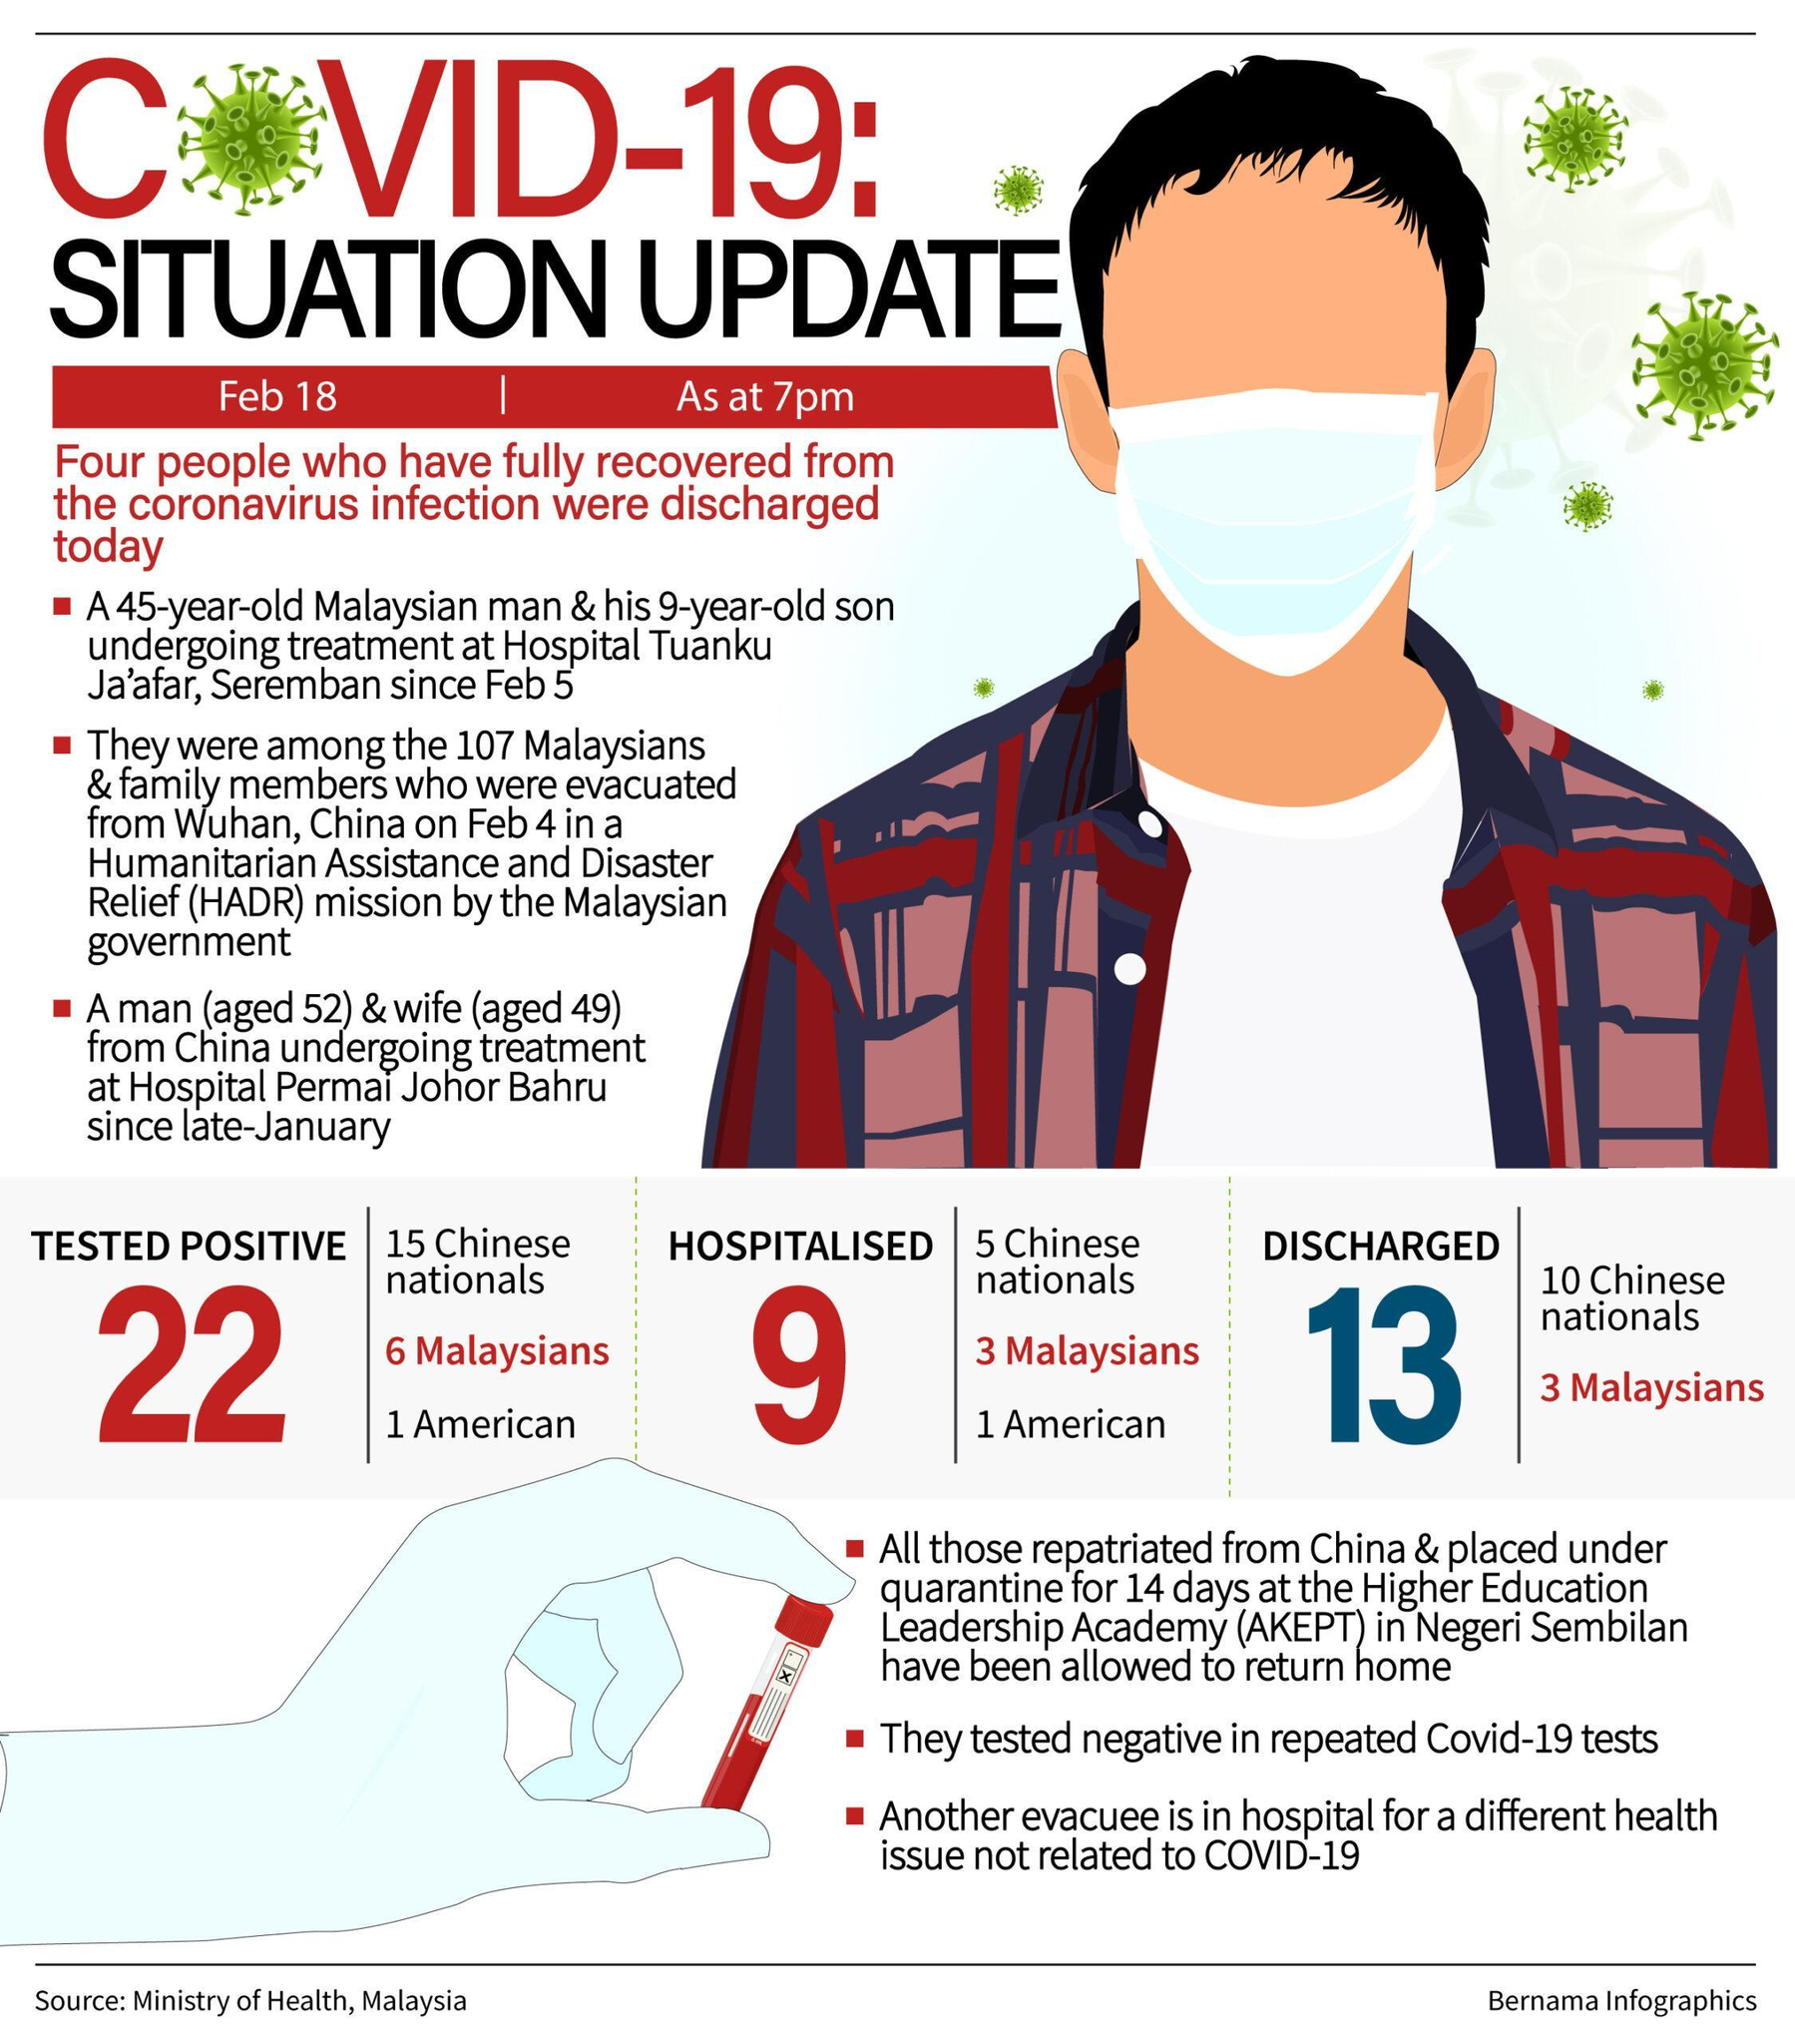How many Chinese nationals were hospitalised in Malaysia as of February 18?
Answer the question with a short phrase. 5 What is the total number of Covid positive people hospitalised in Malaysia as of February 18? 9 How many Americans were tested positive for COVID-19 in Malaysia as of February 18? 1 How many Chinese nationals were discharged from the hospital in Malaysia as of February 18? 10 